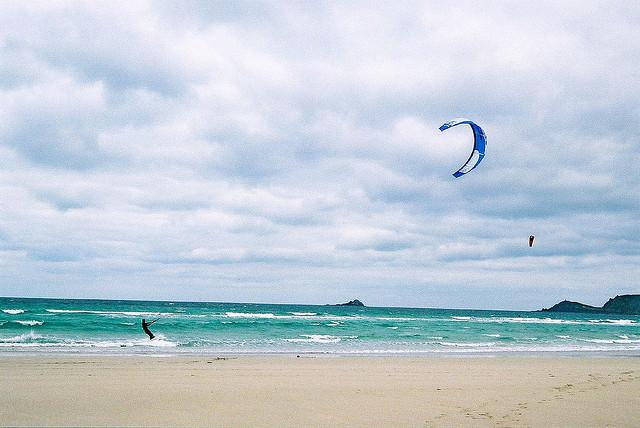What color are the eyes on the edges of the parasail pulling the skier? Please explain your reasoning. white. The edges of the parasail have white dots. 